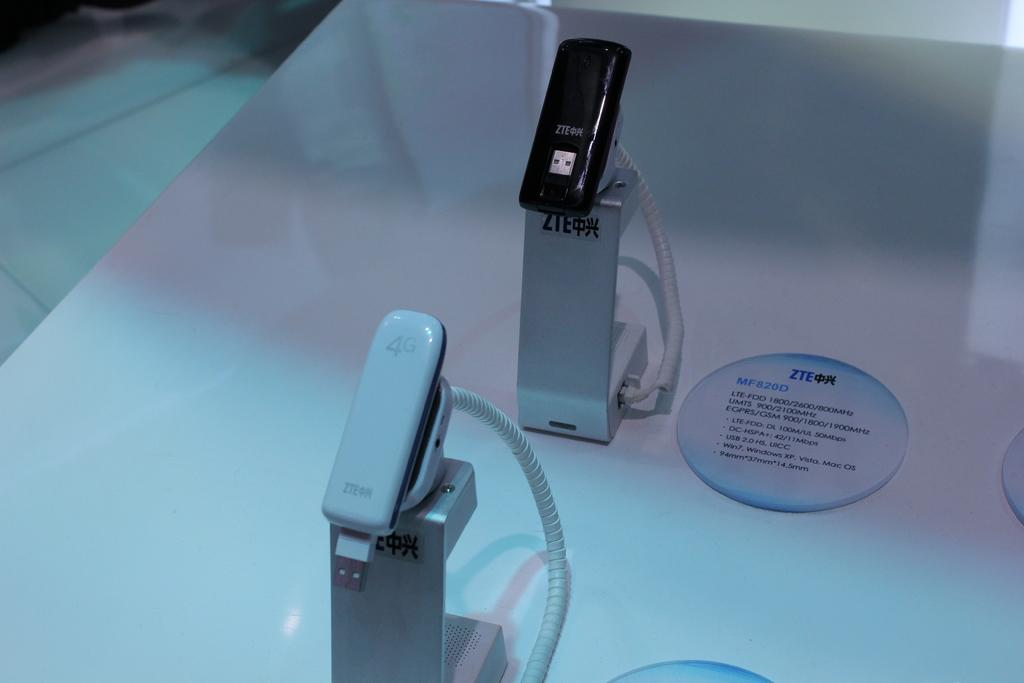<image>
Create a compact narrative representing the image presented. A ZTE logo can be seen next to two phones on displays. 